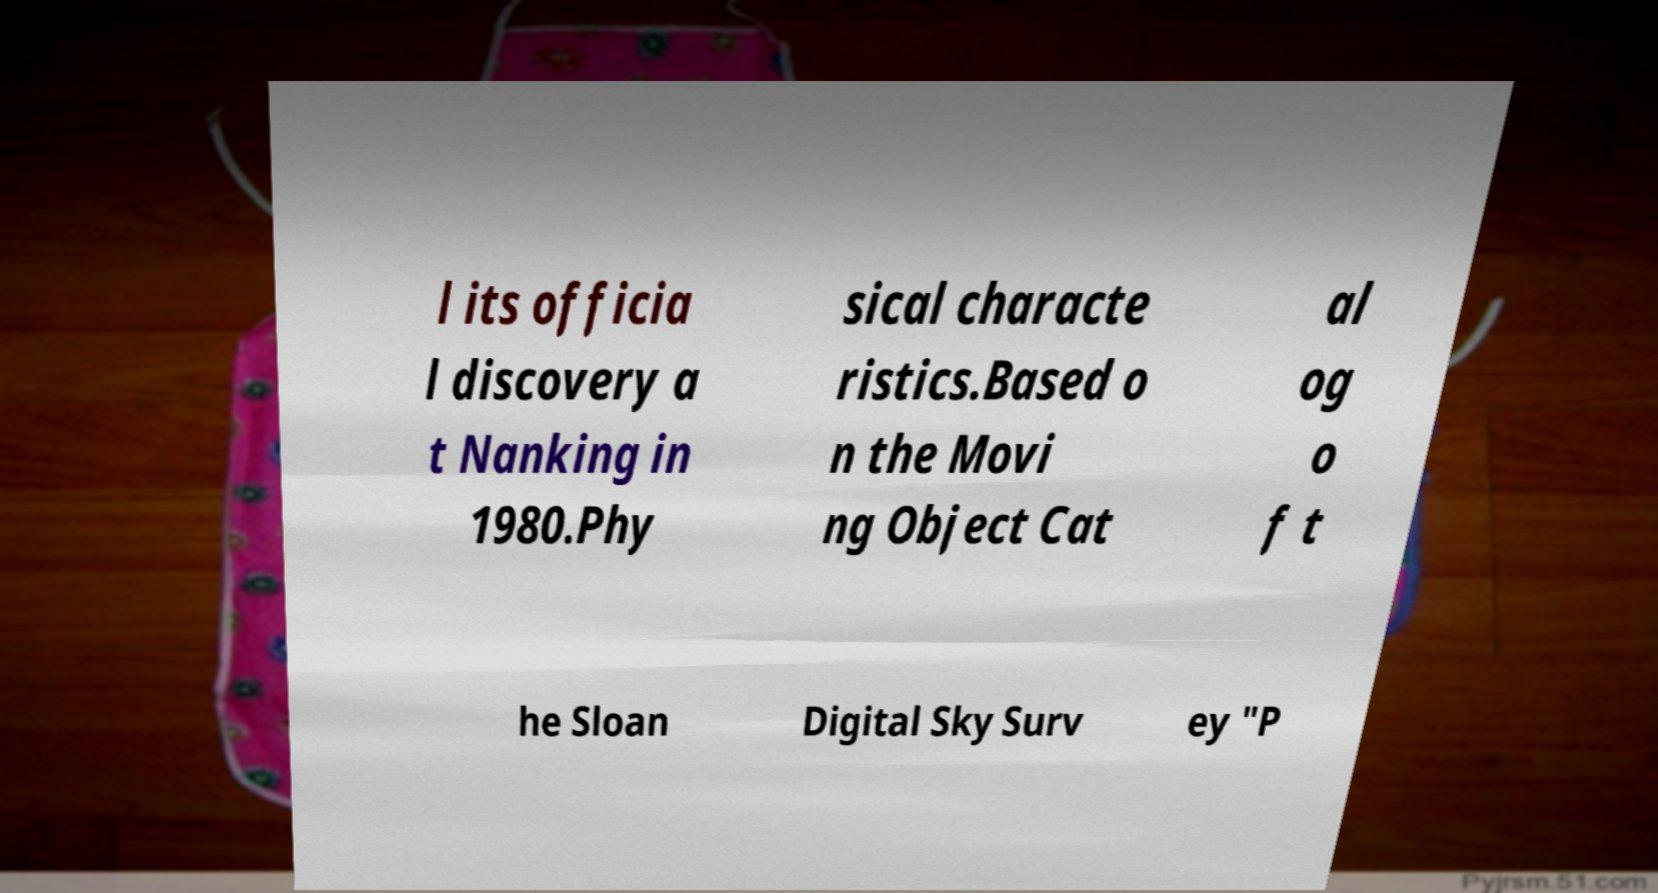For documentation purposes, I need the text within this image transcribed. Could you provide that? l its officia l discovery a t Nanking in 1980.Phy sical characte ristics.Based o n the Movi ng Object Cat al og o f t he Sloan Digital Sky Surv ey "P 